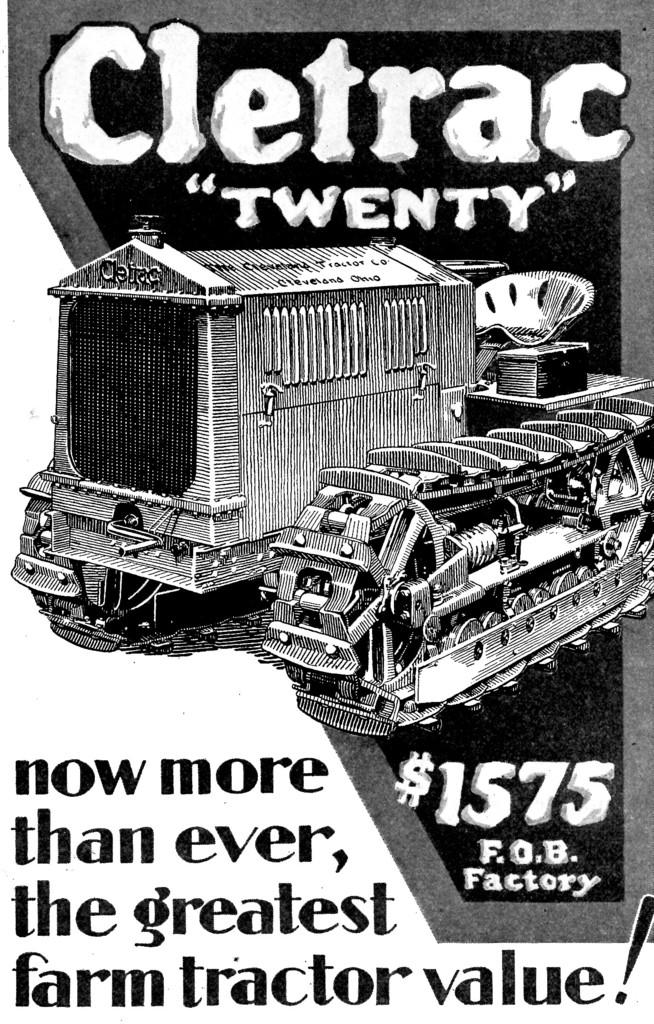What is featured in the image? There is a poster in the image. What can be seen on the poster? There are machines that resemble trains in the middle of the poster. Are there any words or letters on the poster? Yes, there is text on the poster. What type of brick is used to build the attraction in the image? There is no attraction or brick present in the image; it features a poster with machines that resemble trains and text. 